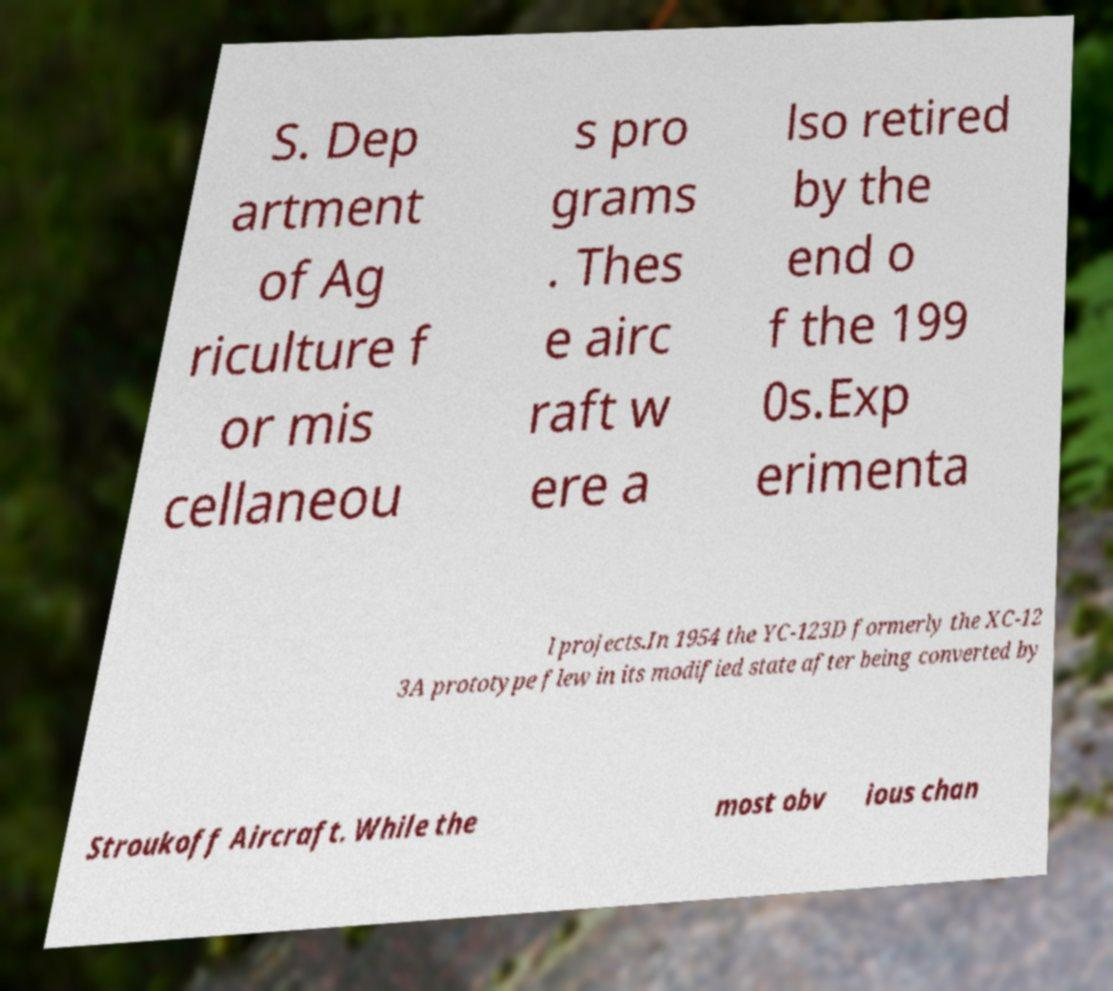Please identify and transcribe the text found in this image. S. Dep artment of Ag riculture f or mis cellaneou s pro grams . Thes e airc raft w ere a lso retired by the end o f the 199 0s.Exp erimenta l projects.In 1954 the YC-123D formerly the XC-12 3A prototype flew in its modified state after being converted by Stroukoff Aircraft. While the most obv ious chan 